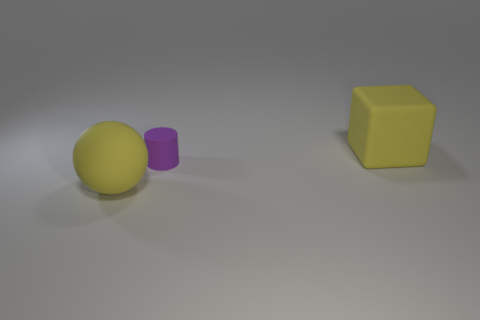How many things are either small rubber cylinders or yellow metallic cylinders?
Offer a very short reply. 1. How big is the yellow rubber object that is in front of the big thing that is right of the large matte object left of the purple rubber thing?
Your answer should be very brief. Large. How many large blocks have the same color as the rubber sphere?
Your answer should be compact. 1. What number of large cubes are the same material as the cylinder?
Offer a terse response. 1. How many objects are either purple shiny cubes or rubber objects that are to the left of the cylinder?
Make the answer very short. 1. What color is the large rubber thing to the left of the large rubber thing that is right of the large yellow rubber thing that is on the left side of the large matte cube?
Offer a terse response. Yellow. What size is the object to the right of the tiny purple matte thing?
Make the answer very short. Large. What number of large objects are either yellow metal cylinders or yellow objects?
Provide a short and direct response. 2. The thing that is in front of the large matte cube and to the right of the big yellow rubber ball is what color?
Provide a short and direct response. Purple. Is there a large thing of the same shape as the small purple object?
Offer a terse response. No. 